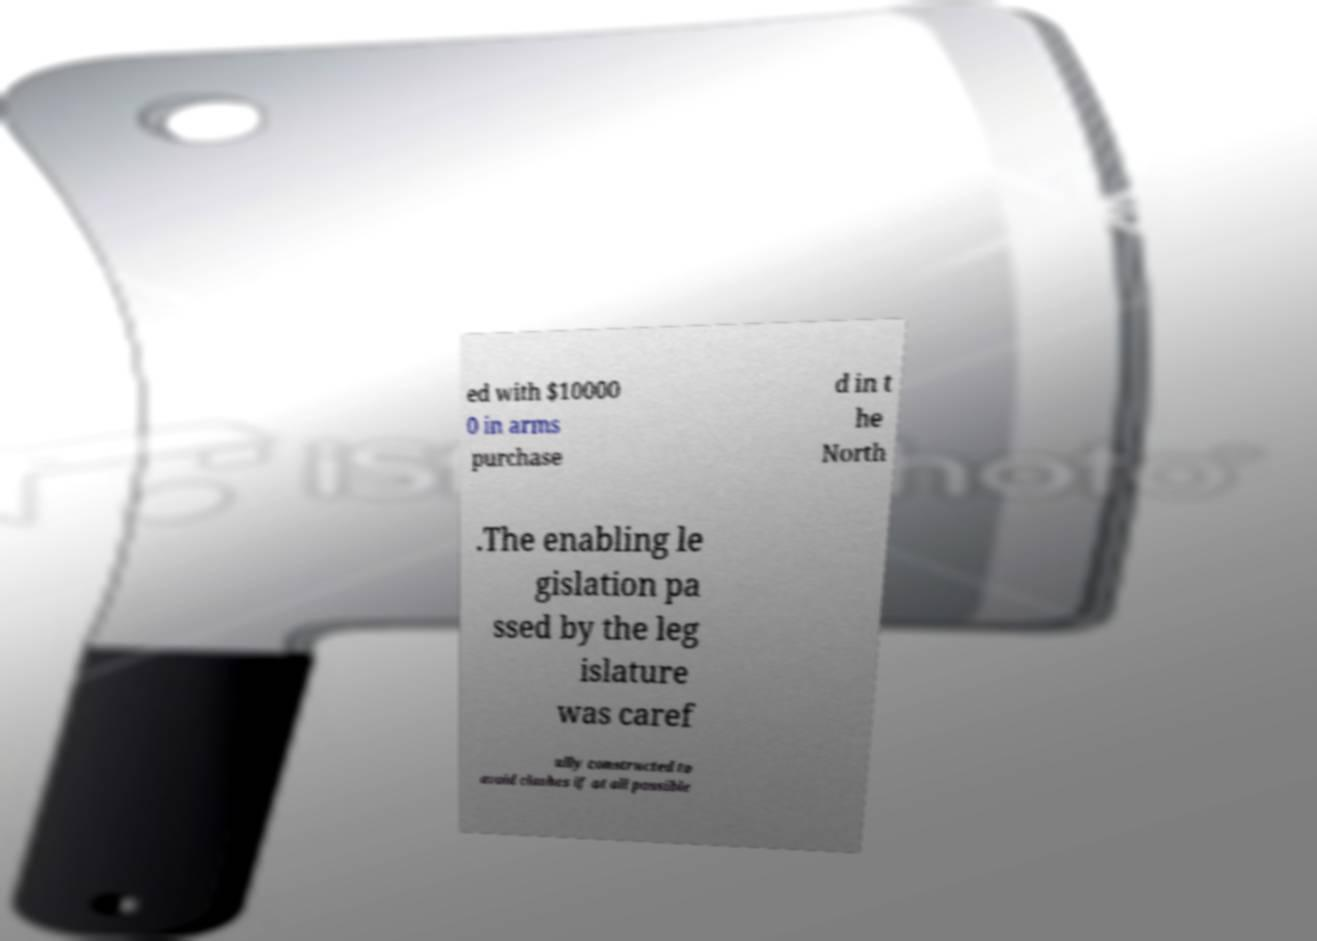I need the written content from this picture converted into text. Can you do that? ed with $10000 0 in arms purchase d in t he North .The enabling le gislation pa ssed by the leg islature was caref ully constructed to avoid clashes if at all possible 